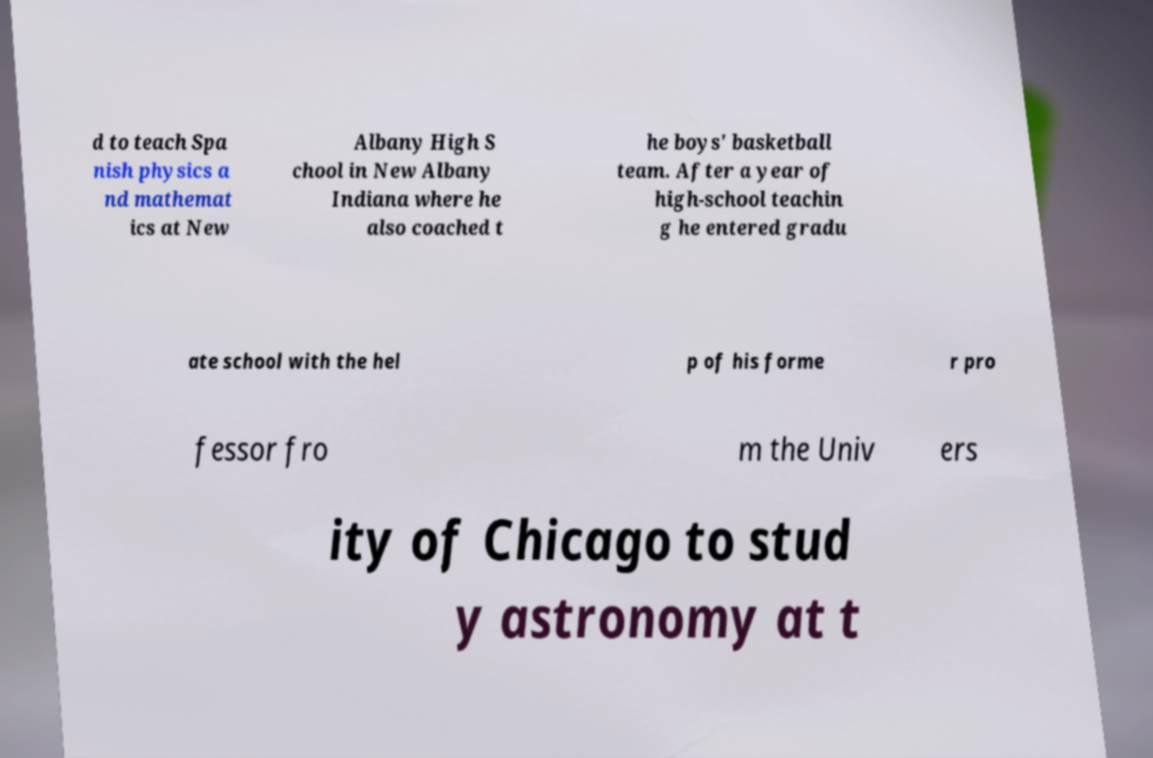I need the written content from this picture converted into text. Can you do that? d to teach Spa nish physics a nd mathemat ics at New Albany High S chool in New Albany Indiana where he also coached t he boys' basketball team. After a year of high-school teachin g he entered gradu ate school with the hel p of his forme r pro fessor fro m the Univ ers ity of Chicago to stud y astronomy at t 